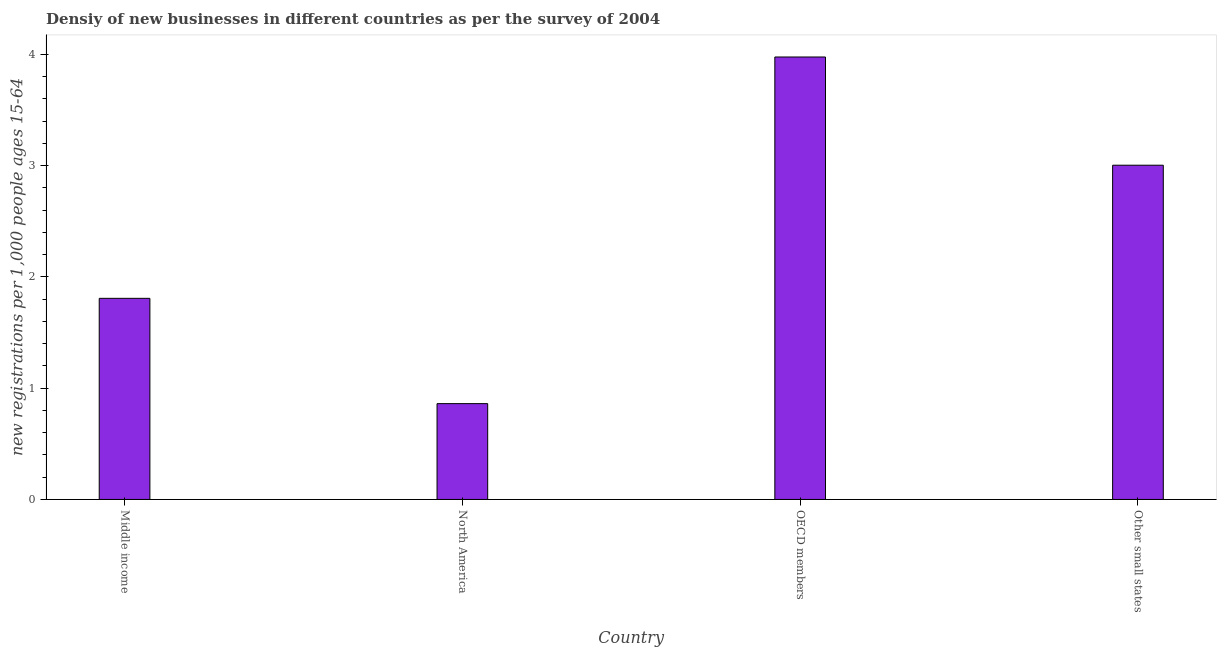Does the graph contain any zero values?
Your response must be concise. No. Does the graph contain grids?
Offer a terse response. No. What is the title of the graph?
Offer a very short reply. Densiy of new businesses in different countries as per the survey of 2004. What is the label or title of the X-axis?
Your answer should be very brief. Country. What is the label or title of the Y-axis?
Your answer should be compact. New registrations per 1,0 people ages 15-64. What is the density of new business in Middle income?
Provide a succinct answer. 1.81. Across all countries, what is the maximum density of new business?
Your answer should be compact. 3.98. Across all countries, what is the minimum density of new business?
Your answer should be very brief. 0.86. In which country was the density of new business maximum?
Provide a succinct answer. OECD members. What is the sum of the density of new business?
Make the answer very short. 9.65. What is the difference between the density of new business in North America and OECD members?
Give a very brief answer. -3.12. What is the average density of new business per country?
Ensure brevity in your answer.  2.41. What is the median density of new business?
Your answer should be compact. 2.41. What is the ratio of the density of new business in North America to that in Other small states?
Offer a very short reply. 0.29. What is the difference between the highest and the second highest density of new business?
Ensure brevity in your answer.  0.97. What is the difference between the highest and the lowest density of new business?
Provide a short and direct response. 3.11. How many countries are there in the graph?
Provide a succinct answer. 4. What is the new registrations per 1,000 people ages 15-64 of Middle income?
Make the answer very short. 1.81. What is the new registrations per 1,000 people ages 15-64 in North America?
Provide a succinct answer. 0.86. What is the new registrations per 1,000 people ages 15-64 of OECD members?
Your answer should be very brief. 3.98. What is the new registrations per 1,000 people ages 15-64 in Other small states?
Your answer should be very brief. 3. What is the difference between the new registrations per 1,000 people ages 15-64 in Middle income and North America?
Give a very brief answer. 0.95. What is the difference between the new registrations per 1,000 people ages 15-64 in Middle income and OECD members?
Provide a short and direct response. -2.17. What is the difference between the new registrations per 1,000 people ages 15-64 in Middle income and Other small states?
Your response must be concise. -1.2. What is the difference between the new registrations per 1,000 people ages 15-64 in North America and OECD members?
Your response must be concise. -3.11. What is the difference between the new registrations per 1,000 people ages 15-64 in North America and Other small states?
Offer a very short reply. -2.14. What is the difference between the new registrations per 1,000 people ages 15-64 in OECD members and Other small states?
Your answer should be compact. 0.97. What is the ratio of the new registrations per 1,000 people ages 15-64 in Middle income to that in North America?
Your response must be concise. 2.1. What is the ratio of the new registrations per 1,000 people ages 15-64 in Middle income to that in OECD members?
Your answer should be compact. 0.46. What is the ratio of the new registrations per 1,000 people ages 15-64 in Middle income to that in Other small states?
Offer a terse response. 0.6. What is the ratio of the new registrations per 1,000 people ages 15-64 in North America to that in OECD members?
Your response must be concise. 0.22. What is the ratio of the new registrations per 1,000 people ages 15-64 in North America to that in Other small states?
Provide a short and direct response. 0.29. What is the ratio of the new registrations per 1,000 people ages 15-64 in OECD members to that in Other small states?
Your response must be concise. 1.32. 